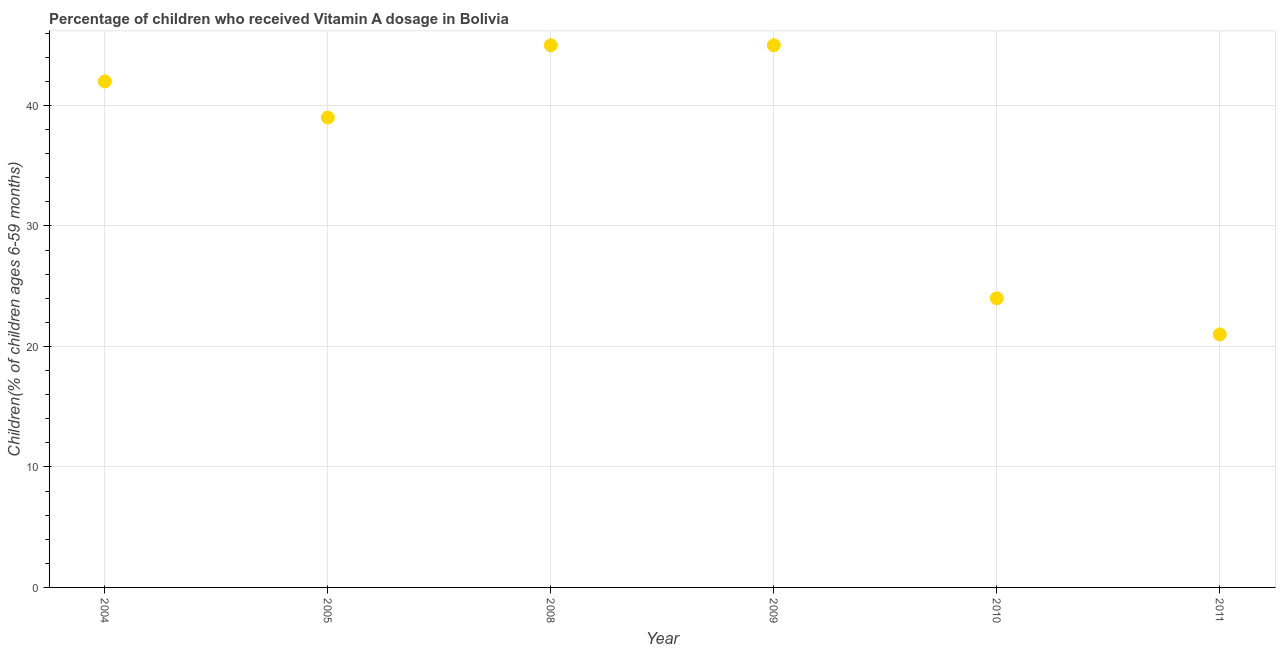What is the vitamin a supplementation coverage rate in 2010?
Give a very brief answer. 24. Across all years, what is the maximum vitamin a supplementation coverage rate?
Provide a short and direct response. 45. Across all years, what is the minimum vitamin a supplementation coverage rate?
Offer a terse response. 21. In which year was the vitamin a supplementation coverage rate maximum?
Your answer should be very brief. 2008. What is the sum of the vitamin a supplementation coverage rate?
Give a very brief answer. 216. What is the difference between the vitamin a supplementation coverage rate in 2004 and 2011?
Keep it short and to the point. 21. What is the median vitamin a supplementation coverage rate?
Ensure brevity in your answer.  40.5. In how many years, is the vitamin a supplementation coverage rate greater than 16 %?
Your response must be concise. 6. Do a majority of the years between 2009 and 2008 (inclusive) have vitamin a supplementation coverage rate greater than 30 %?
Keep it short and to the point. No. What is the ratio of the vitamin a supplementation coverage rate in 2004 to that in 2008?
Provide a succinct answer. 0.93. Is the vitamin a supplementation coverage rate in 2004 less than that in 2009?
Your answer should be compact. Yes. Is the difference between the vitamin a supplementation coverage rate in 2004 and 2010 greater than the difference between any two years?
Offer a terse response. No. What is the difference between the highest and the second highest vitamin a supplementation coverage rate?
Offer a terse response. 0. What is the difference between the highest and the lowest vitamin a supplementation coverage rate?
Your answer should be very brief. 24. Does the graph contain grids?
Your answer should be compact. Yes. What is the title of the graph?
Your response must be concise. Percentage of children who received Vitamin A dosage in Bolivia. What is the label or title of the X-axis?
Provide a succinct answer. Year. What is the label or title of the Y-axis?
Ensure brevity in your answer.  Children(% of children ages 6-59 months). What is the Children(% of children ages 6-59 months) in 2004?
Provide a succinct answer. 42. What is the Children(% of children ages 6-59 months) in 2005?
Your answer should be compact. 39. What is the Children(% of children ages 6-59 months) in 2008?
Provide a short and direct response. 45. What is the difference between the Children(% of children ages 6-59 months) in 2004 and 2009?
Provide a short and direct response. -3. What is the difference between the Children(% of children ages 6-59 months) in 2004 and 2010?
Your answer should be very brief. 18. What is the difference between the Children(% of children ages 6-59 months) in 2004 and 2011?
Offer a terse response. 21. What is the difference between the Children(% of children ages 6-59 months) in 2005 and 2011?
Make the answer very short. 18. What is the difference between the Children(% of children ages 6-59 months) in 2008 and 2009?
Offer a very short reply. 0. What is the difference between the Children(% of children ages 6-59 months) in 2009 and 2010?
Offer a terse response. 21. What is the difference between the Children(% of children ages 6-59 months) in 2009 and 2011?
Offer a terse response. 24. What is the ratio of the Children(% of children ages 6-59 months) in 2004 to that in 2005?
Make the answer very short. 1.08. What is the ratio of the Children(% of children ages 6-59 months) in 2004 to that in 2008?
Offer a terse response. 0.93. What is the ratio of the Children(% of children ages 6-59 months) in 2004 to that in 2009?
Keep it short and to the point. 0.93. What is the ratio of the Children(% of children ages 6-59 months) in 2004 to that in 2010?
Offer a very short reply. 1.75. What is the ratio of the Children(% of children ages 6-59 months) in 2005 to that in 2008?
Give a very brief answer. 0.87. What is the ratio of the Children(% of children ages 6-59 months) in 2005 to that in 2009?
Provide a succinct answer. 0.87. What is the ratio of the Children(% of children ages 6-59 months) in 2005 to that in 2010?
Give a very brief answer. 1.62. What is the ratio of the Children(% of children ages 6-59 months) in 2005 to that in 2011?
Offer a very short reply. 1.86. What is the ratio of the Children(% of children ages 6-59 months) in 2008 to that in 2010?
Provide a short and direct response. 1.88. What is the ratio of the Children(% of children ages 6-59 months) in 2008 to that in 2011?
Provide a succinct answer. 2.14. What is the ratio of the Children(% of children ages 6-59 months) in 2009 to that in 2010?
Make the answer very short. 1.88. What is the ratio of the Children(% of children ages 6-59 months) in 2009 to that in 2011?
Your answer should be compact. 2.14. What is the ratio of the Children(% of children ages 6-59 months) in 2010 to that in 2011?
Your response must be concise. 1.14. 